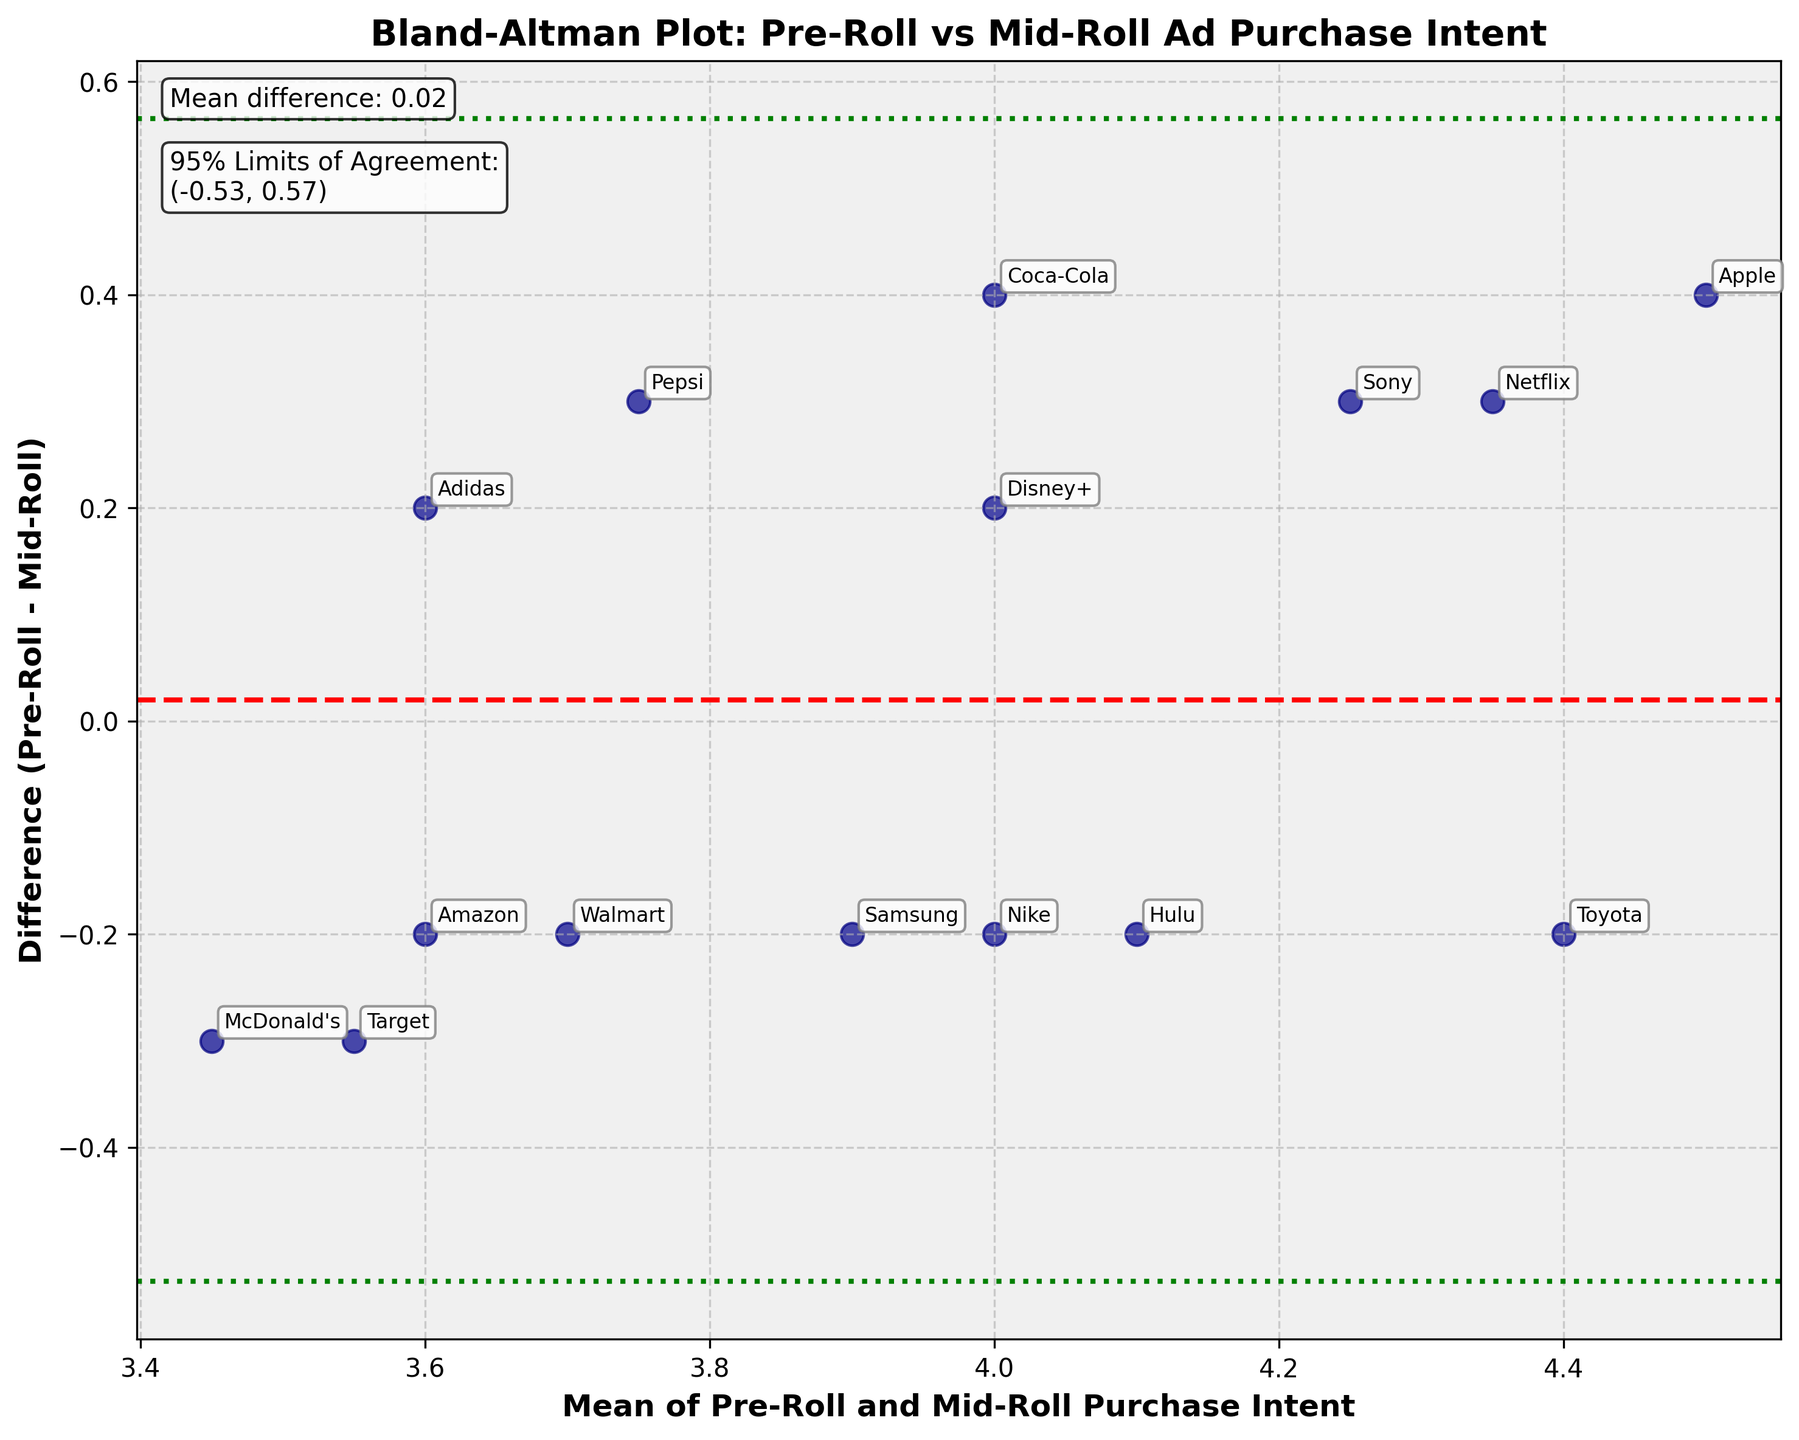What's the title of the plot? The title of the plot is usually located at the top center of the figure. In this plot, the title reads "Bland-Altman Plot: Pre-Roll vs Mid-Roll Ad Purchase Intent".
Answer: Bland-Altman Plot: Pre-Roll vs Mid-Roll Ad Purchase Intent How many data points are shown on the plot? Each data point represents a brand and is indicated by a blue dot with labels. By counting the labels or dots, we can see there are 15.
Answer: 15 What are the mean and standard deviation of the differences between Pre-Roll and Mid-Roll purchase intent? The standard Bland-Altman plot provides these values on the graph. The mean difference is written at the top left of the plot, with the label "Mean difference:". The standard deviation isn't directly mentioned, but the 95% Limits of Agreement calculation involves standard deviation.
Answer: Mean difference: 0.04, Std Dev not directly mentioned What is the lowest difference value, and for which brand is it? The lowest difference value is found at the lowest point on the y-axis in the scatter plot, labeled with the corresponding brand name. The lowest point is for Toyota.
Answer: Brand: Toyota, Difference: -0.2 Which brand has the highest mean purchase intent across Pre-Roll and Mid-Roll ads? To find this, look for the highest point along the x-axis, since it represents the highest mean value. The brand label at this point is Apple.
Answer: Apple What color are the confidence limit lines, and what do they represent? The confidence limit lines are green and dotted. They represent the 95% Limits of Agreement, which show the range in which 95% of the differences between Pre-Roll and Mid-Roll purchase intents are expected to fall.
Answer: Green, dotted lines What is the difference between the Pre-Roll and Mid-Roll purchase intent for Coca-Cola? The difference can be found by looking for the label "Coca-Cola" and noting its vertical position. Coca-Cola has a difference value of 0.4 on the y-axis.
Answer: 0.4 Are there any brands that show a negative difference between Pre-Roll and Mid-Roll purchase intents? If yes, name one. A negative difference occurs when the data point falls below the red dashed mean difference line. Toyota is one example with a negative difference.
Answer: Yes, Toyota What does the red dashed line in the plot indicate? The red dashed line represents the mean difference between Pre-Roll and Mid-Roll purchase intents across all brands. It indicates the average level of difference, which is 0.04 in this plot.
Answer: Mean difference Which brand has the closest difference to the mean difference, and what is that difference? The closest point to the red dashed line (mean difference) represents this brand. McDonald's has approximately the same value as the mean, which is around 0.04.
Answer: McDonald's, Difference: 0.3 